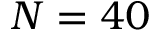Convert formula to latex. <formula><loc_0><loc_0><loc_500><loc_500>N = 4 0</formula> 